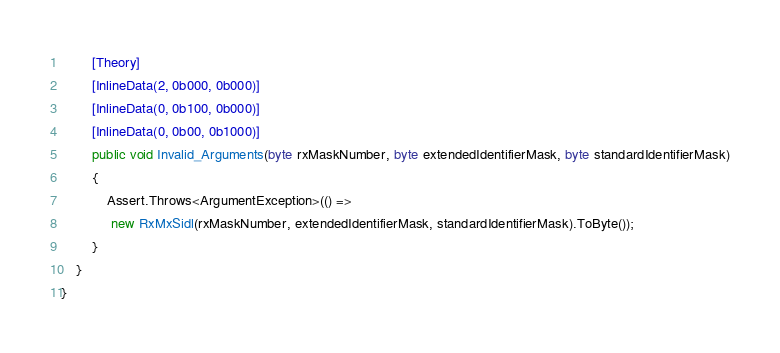Convert code to text. <code><loc_0><loc_0><loc_500><loc_500><_C#_>        [Theory]
        [InlineData(2, 0b000, 0b000)]
        [InlineData(0, 0b100, 0b000)]
        [InlineData(0, 0b00, 0b1000)]
        public void Invalid_Arguments(byte rxMaskNumber, byte extendedIdentifierMask, byte standardIdentifierMask)
        {
            Assert.Throws<ArgumentException>(() =>
             new RxMxSidl(rxMaskNumber, extendedIdentifierMask, standardIdentifierMask).ToByte());
        }
    }
}
</code> 